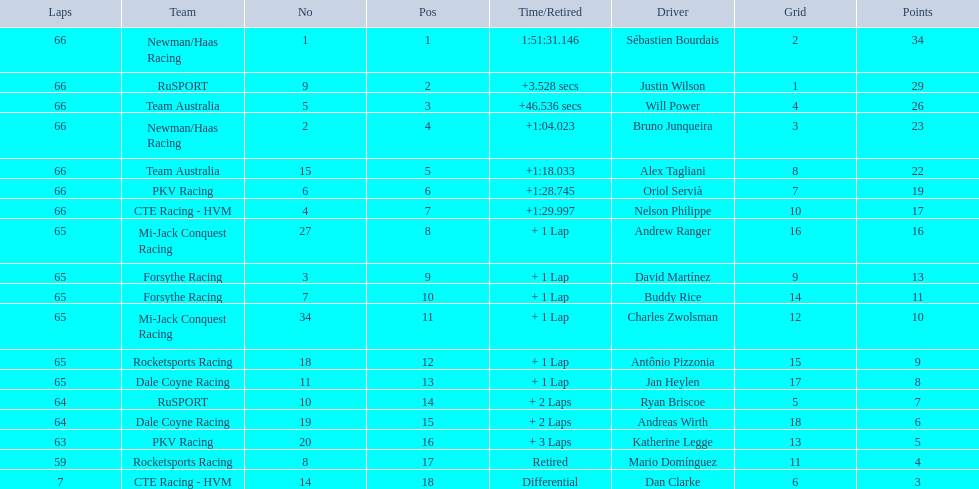Rice finished 10th. who finished next? Charles Zwolsman. 